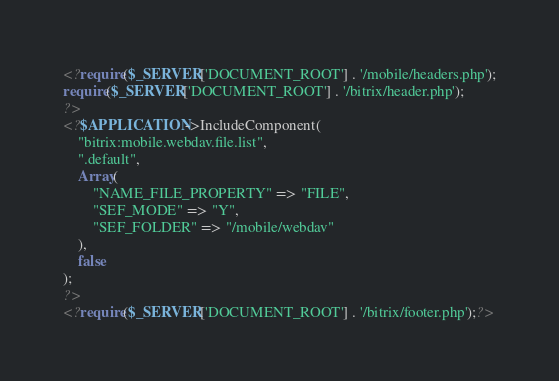Convert code to text. <code><loc_0><loc_0><loc_500><loc_500><_PHP_><?require($_SERVER['DOCUMENT_ROOT'] . '/mobile/headers.php');
require($_SERVER['DOCUMENT_ROOT'] . '/bitrix/header.php');
?>
<?$APPLICATION->IncludeComponent(
	"bitrix:mobile.webdav.file.list",
	".default",
	Array(
		"NAME_FILE_PROPERTY" => "FILE",
		"SEF_MODE" => "Y",
		"SEF_FOLDER" => "/mobile/webdav"
	),
	false
);
?>
<?require($_SERVER['DOCUMENT_ROOT'] . '/bitrix/footer.php');?></code> 